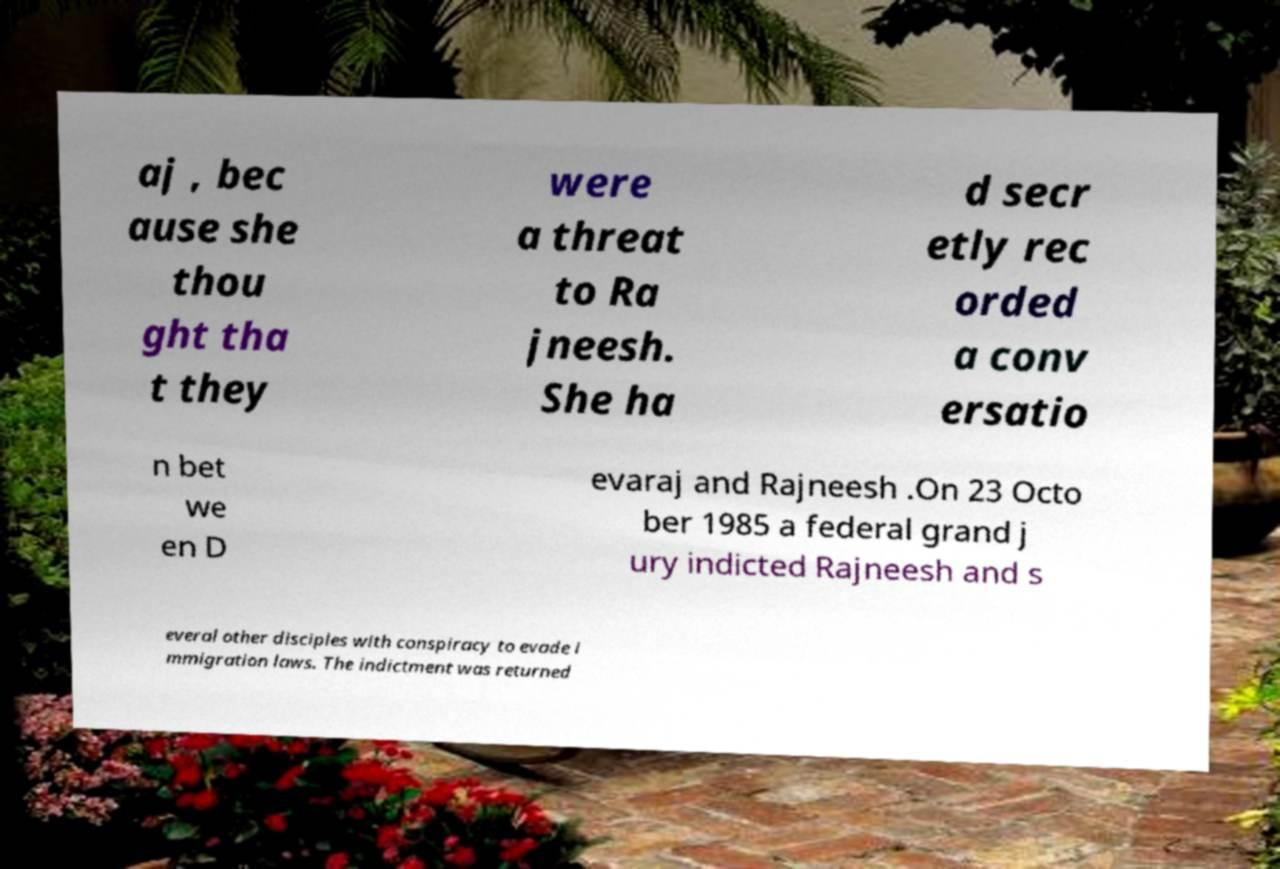There's text embedded in this image that I need extracted. Can you transcribe it verbatim? aj , bec ause she thou ght tha t they were a threat to Ra jneesh. She ha d secr etly rec orded a conv ersatio n bet we en D evaraj and Rajneesh .On 23 Octo ber 1985 a federal grand j ury indicted Rajneesh and s everal other disciples with conspiracy to evade i mmigration laws. The indictment was returned 